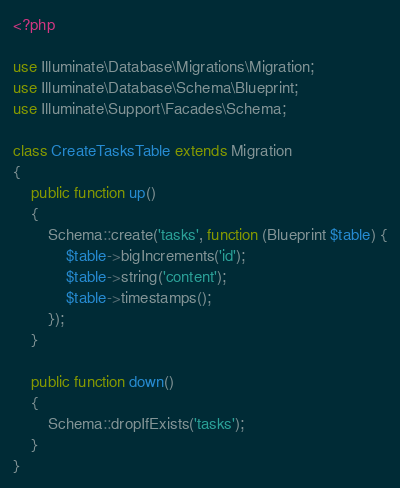<code> <loc_0><loc_0><loc_500><loc_500><_PHP_><?php

use Illuminate\Database\Migrations\Migration;
use Illuminate\Database\Schema\Blueprint;
use Illuminate\Support\Facades\Schema;

class CreateTasksTable extends Migration
{
    public function up()
    {
        Schema::create('tasks', function (Blueprint $table) {
            $table->bigIncrements('id');
            $table->string('content');
            $table->timestamps();
        });
    }

    public function down()
    {
        Schema::dropIfExists('tasks');
    }
}
</code> 